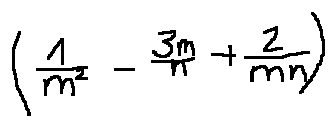Convert formula to latex. <formula><loc_0><loc_0><loc_500><loc_500>( \frac { 1 } { m ^ { 2 } } - \frac { 3 m } { n } + \frac { 2 } { m n } )</formula> 